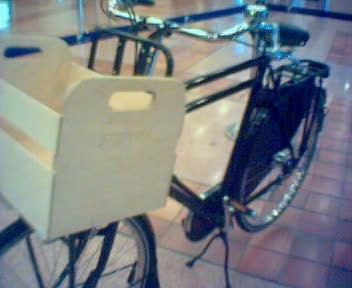What type of bicycle is shown in this image? The image displays a utility bicycle, characterized by its sturdy frame, front cargo basket, and an upright seating position, designed for practical use rather than speed. 